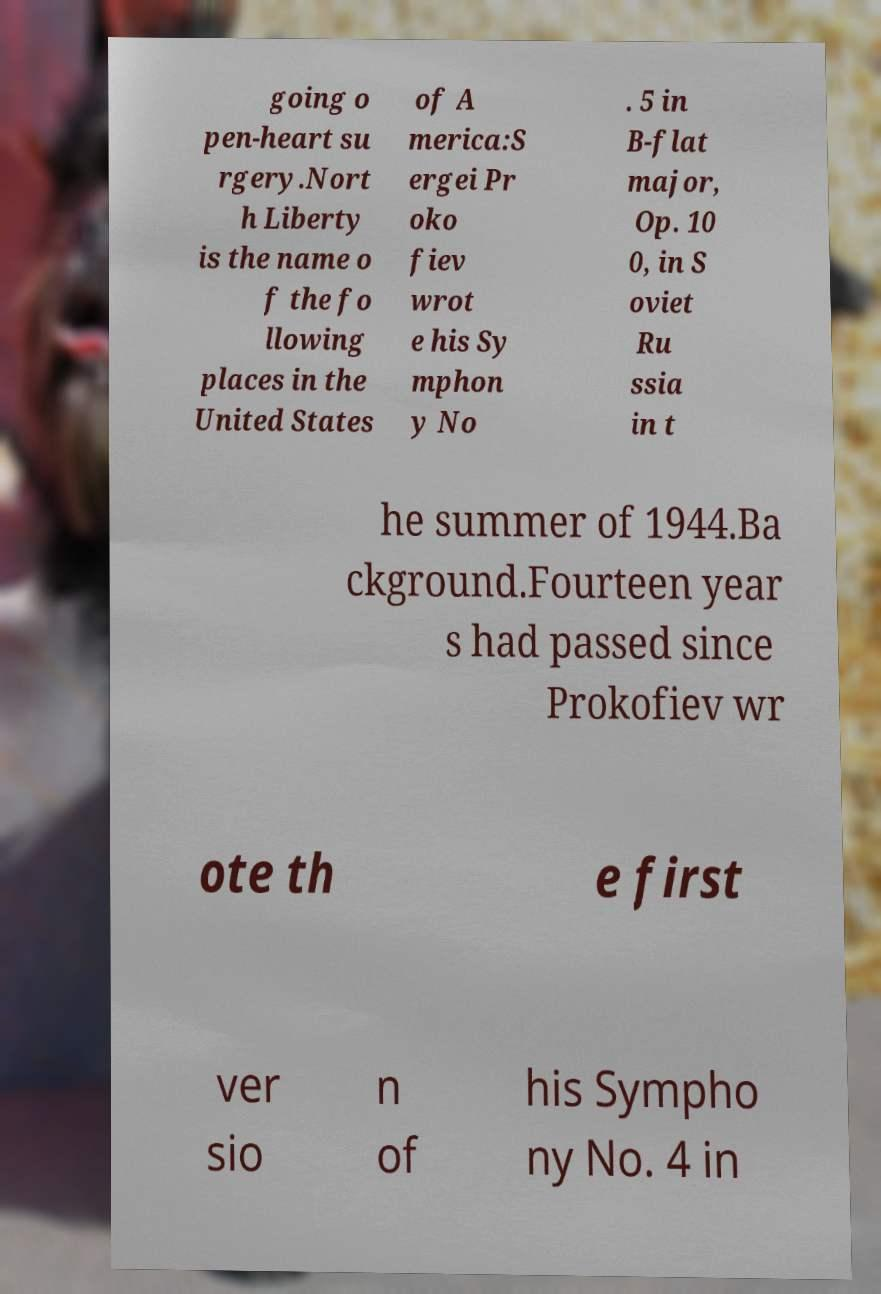For documentation purposes, I need the text within this image transcribed. Could you provide that? going o pen-heart su rgery.Nort h Liberty is the name o f the fo llowing places in the United States of A merica:S ergei Pr oko fiev wrot e his Sy mphon y No . 5 in B-flat major, Op. 10 0, in S oviet Ru ssia in t he summer of 1944.Ba ckground.Fourteen year s had passed since Prokofiev wr ote th e first ver sio n of his Sympho ny No. 4 in 